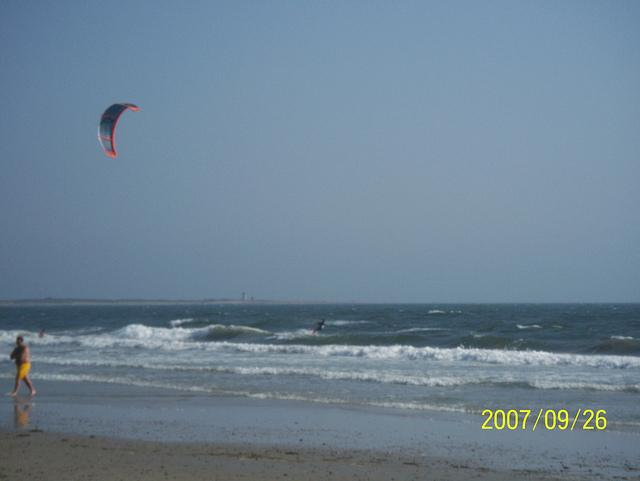How much older is this man now? fourteen years 